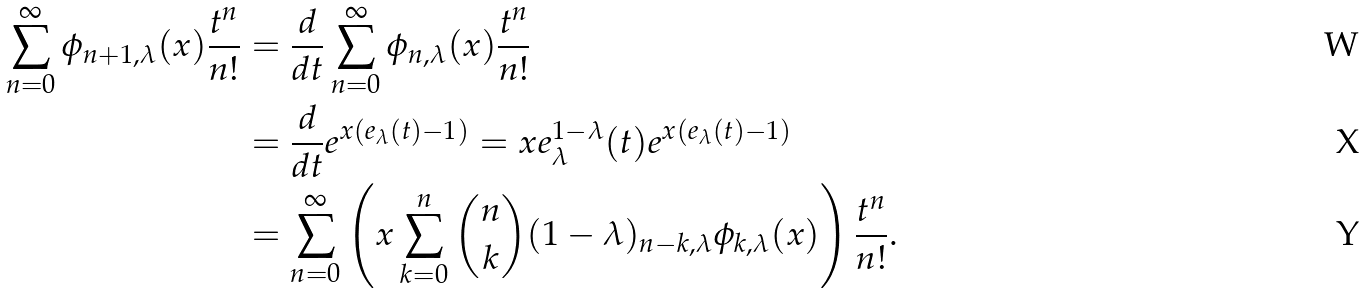Convert formula to latex. <formula><loc_0><loc_0><loc_500><loc_500>\sum _ { n = 0 } ^ { \infty } \phi _ { n + 1 , \lambda } ( x ) \frac { t ^ { n } } { n ! } & = \frac { d } { d t } \sum _ { n = 0 } ^ { \infty } \phi _ { n , \lambda } ( x ) \frac { t ^ { n } } { n ! } \\ & = \frac { d } { d t } e ^ { x ( e _ { \lambda } ( t ) - 1 ) } = x e _ { \lambda } ^ { 1 - \lambda } ( t ) e ^ { x ( e _ { \lambda } ( t ) - 1 ) } \\ & = \sum _ { n = 0 } ^ { \infty } \left ( x \sum _ { k = 0 } ^ { n } \binom { n } { k } ( 1 - \lambda ) _ { n - k , \lambda } \phi _ { k , \lambda } ( x ) \right ) \frac { t ^ { n } } { n ! } .</formula> 